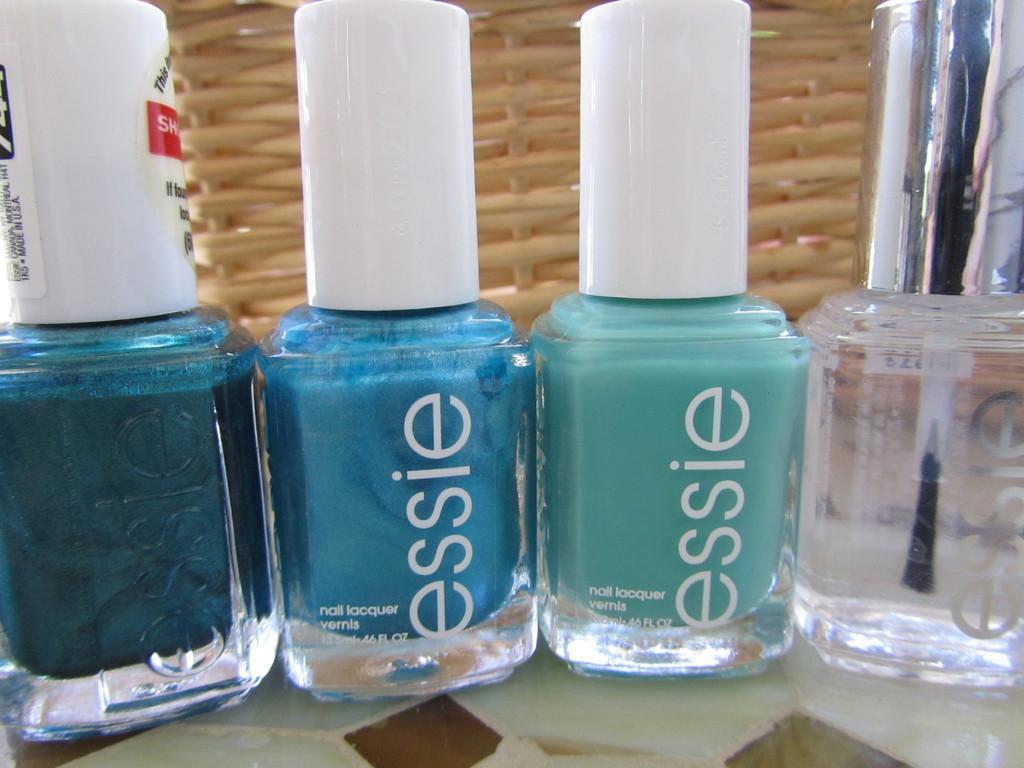In one or two sentences, can you explain what this image depicts? In this image, we can see some nail polish bottles. 